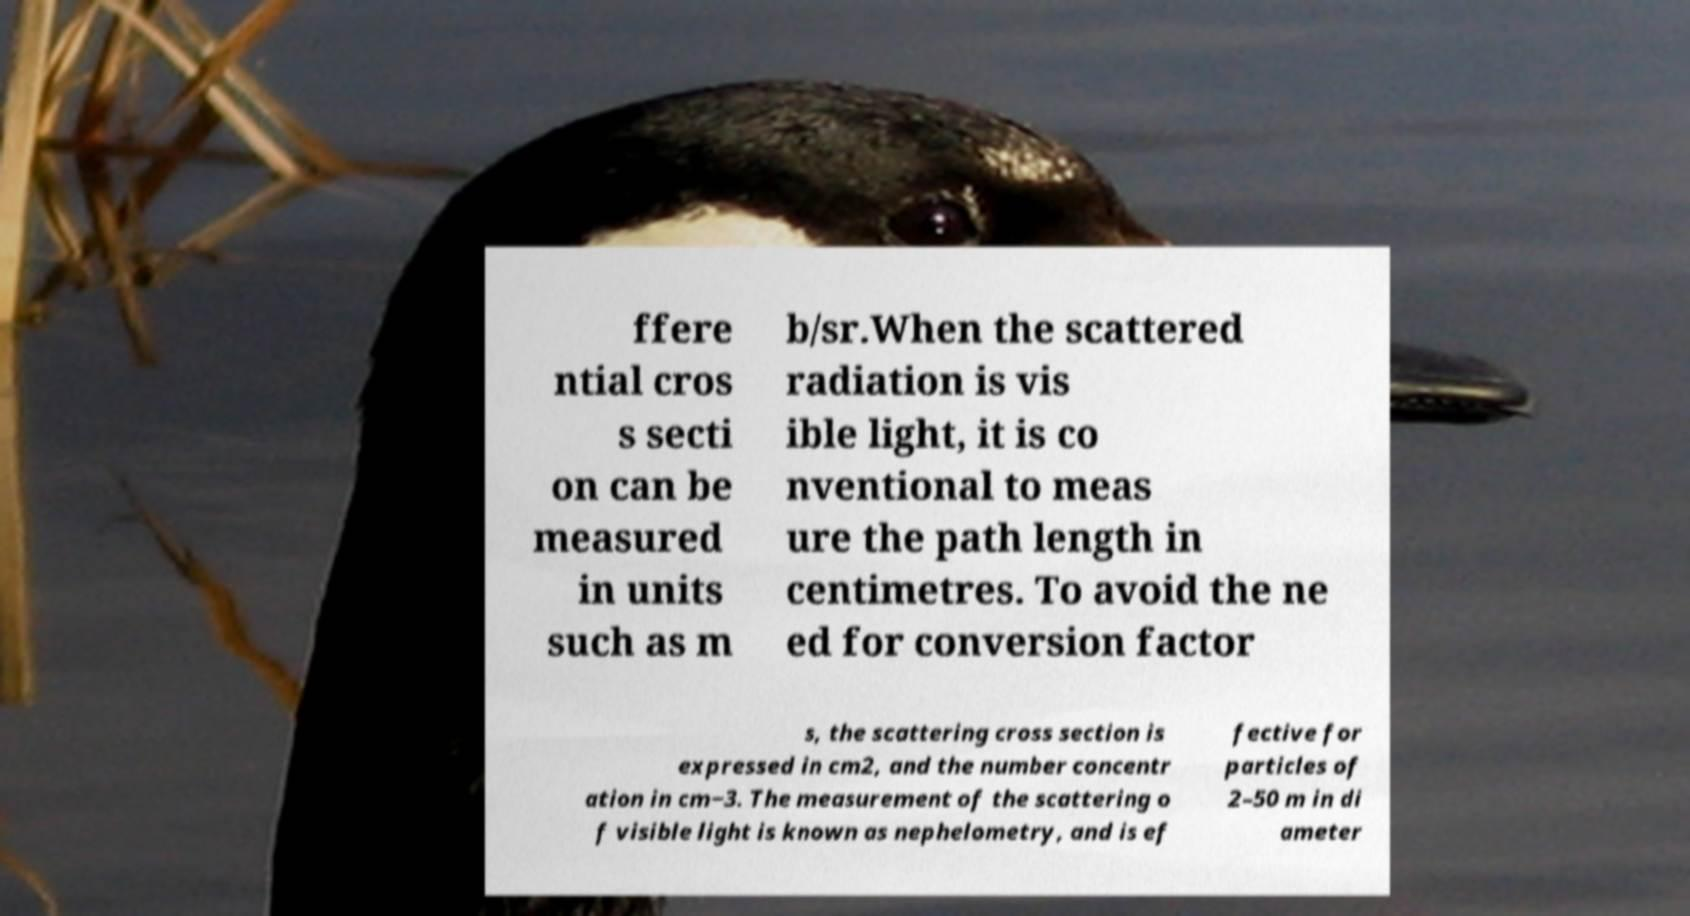What messages or text are displayed in this image? I need them in a readable, typed format. ffere ntial cros s secti on can be measured in units such as m b/sr.When the scattered radiation is vis ible light, it is co nventional to meas ure the path length in centimetres. To avoid the ne ed for conversion factor s, the scattering cross section is expressed in cm2, and the number concentr ation in cm−3. The measurement of the scattering o f visible light is known as nephelometry, and is ef fective for particles of 2–50 m in di ameter 